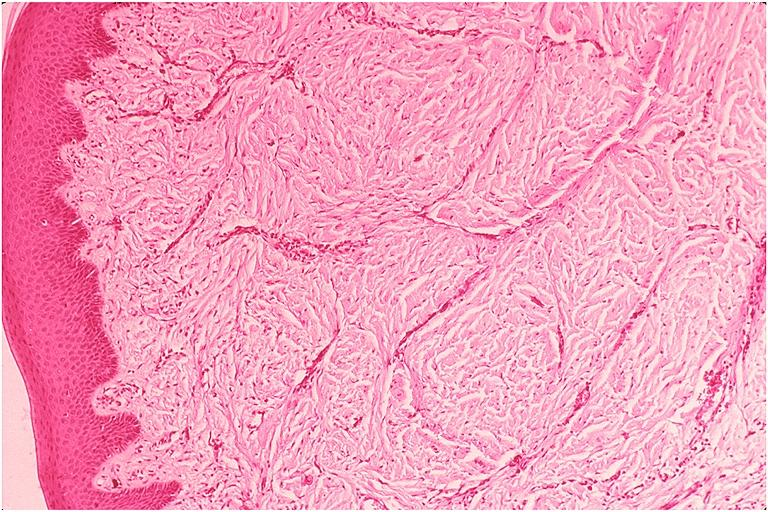what does this image show?
Answer the question using a single word or phrase. Epulis fissuratum 